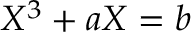Convert formula to latex. <formula><loc_0><loc_0><loc_500><loc_500>X ^ { 3 } + a X = b</formula> 